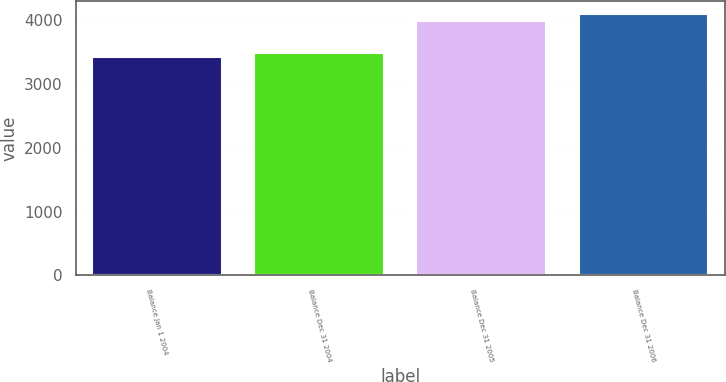Convert chart. <chart><loc_0><loc_0><loc_500><loc_500><bar_chart><fcel>Balance Jan 1 2004<fcel>Balance Dec 31 2004<fcel>Balance Dec 31 2005<fcel>Balance Dec 31 2006<nl><fcel>3428<fcel>3495.3<fcel>3984<fcel>4101<nl></chart> 